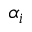<formula> <loc_0><loc_0><loc_500><loc_500>\alpha _ { i }</formula> 